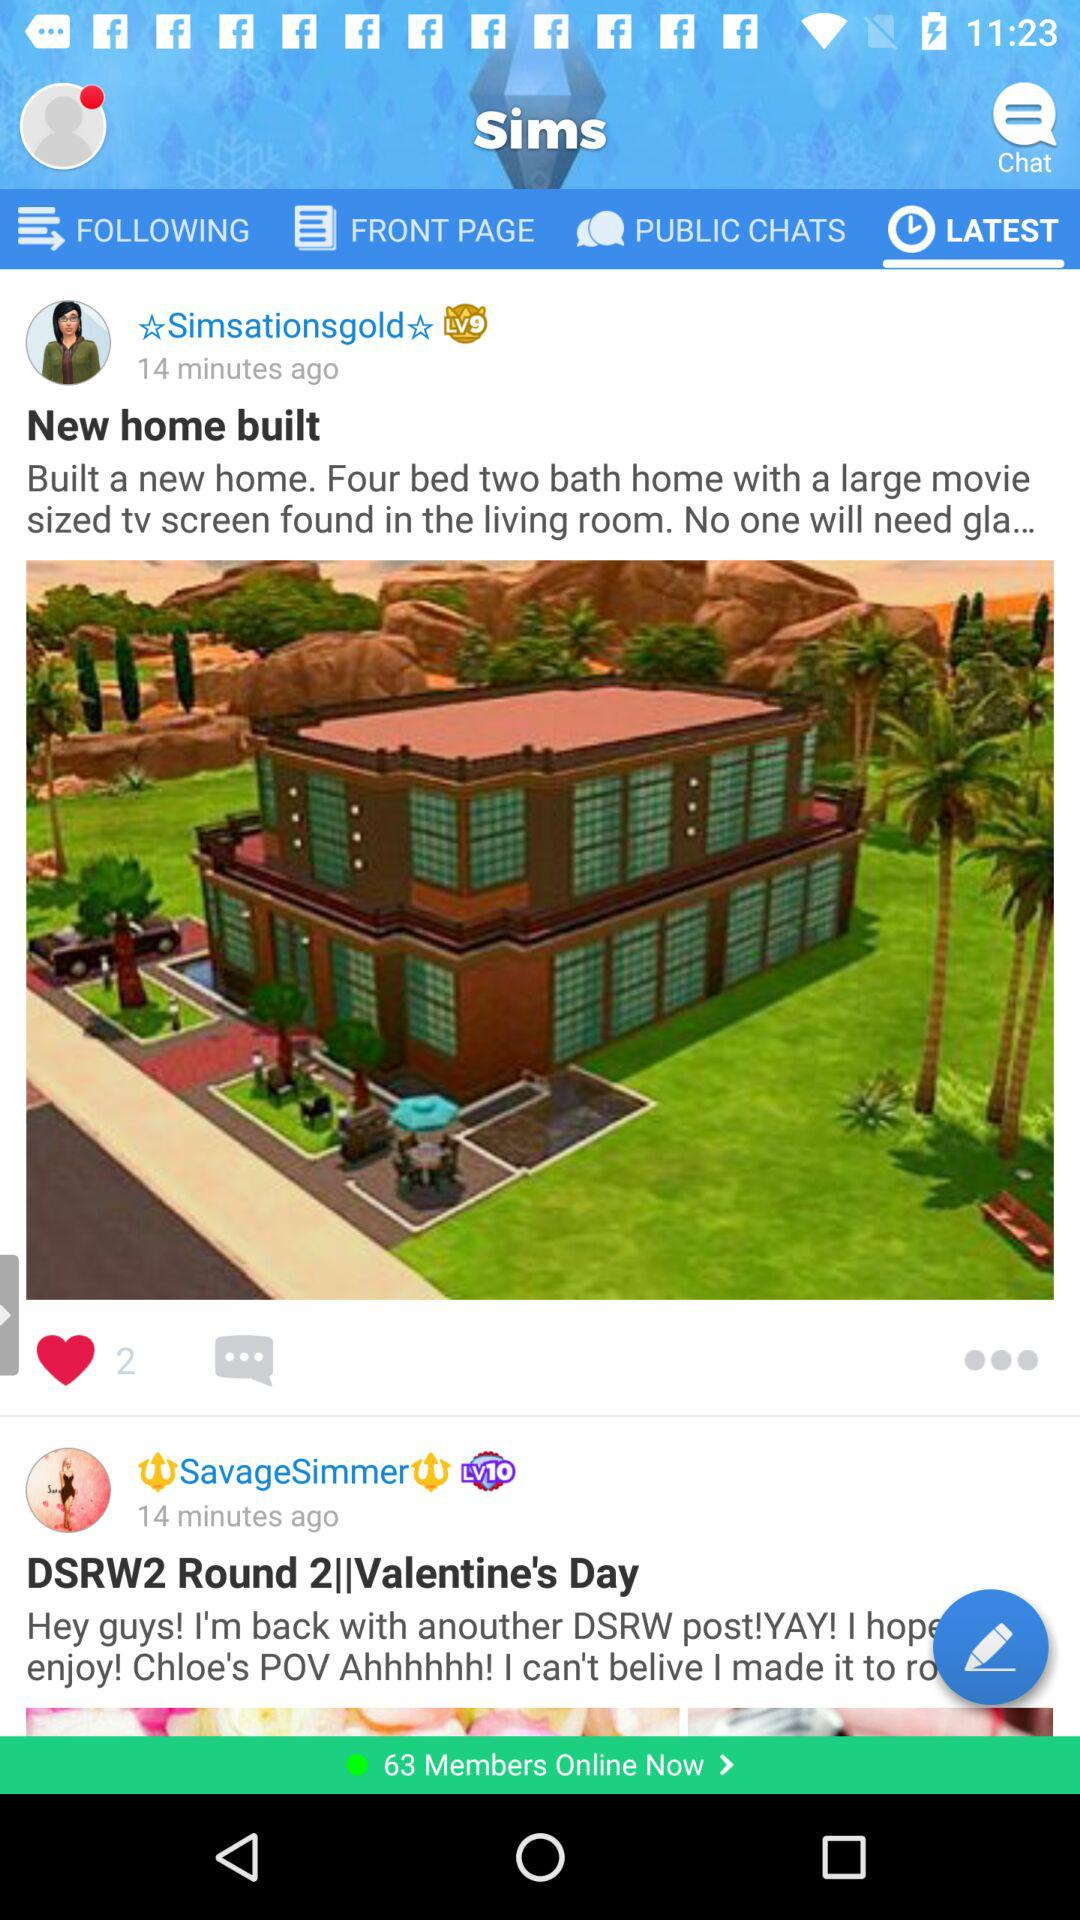How many hearts are on the posts?
Answer the question using a single word or phrase. 2 